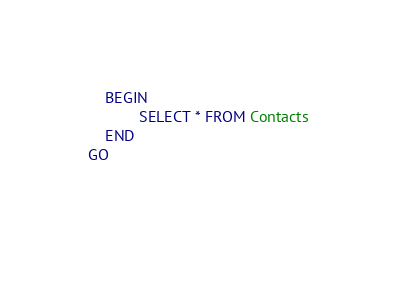<code> <loc_0><loc_0><loc_500><loc_500><_SQL_>	BEGIN
			SELECT * FROM Contacts
	END
GO
	
	</code> 